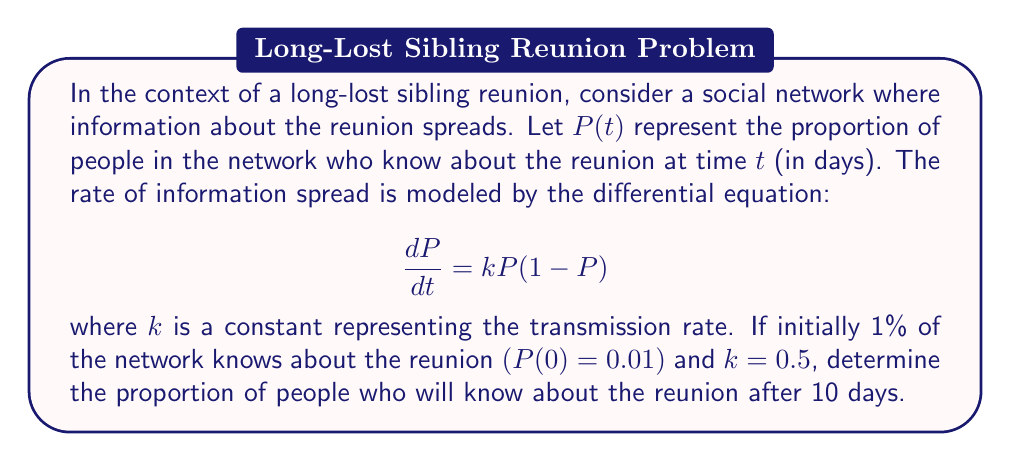Provide a solution to this math problem. To solve this problem, we need to use the logistic differential equation and its solution.

1) The given differential equation is a logistic growth model:
   $$\frac{dP}{dt} = kP(1-P)$$

2) The solution to this equation is:
   $$P(t) = \frac{P_0e^{kt}}{1-P_0+P_0e^{kt}}$$
   where $P_0$ is the initial proportion.

3) We're given:
   $P_0 = 0.01$ (initial 1%)
   $k = 0.5$
   $t = 10$ days

4) Let's substitute these values into the solution:
   $$P(10) = \frac{0.01e^{0.5(10)}}{1-0.01+0.01e^{0.5(10)}}$$

5) Simplify:
   $$P(10) = \frac{0.01e^5}{0.99+0.01e^5}$$

6) Calculate $e^5 \approx 148.4132$:
   $$P(10) = \frac{0.01(148.4132)}{0.99+0.01(148.4132)}$$

7) Simplify:
   $$P(10) = \frac{1.484132}{0.99+1.484132} = \frac{1.484132}{2.474132}$$

8) Calculate the final result:
   $$P(10) \approx 0.5999 \approx 0.60$$

Therefore, after 10 days, approximately 60% of the network will know about the reunion.
Answer: $P(10) \approx 0.60$ or 60% 